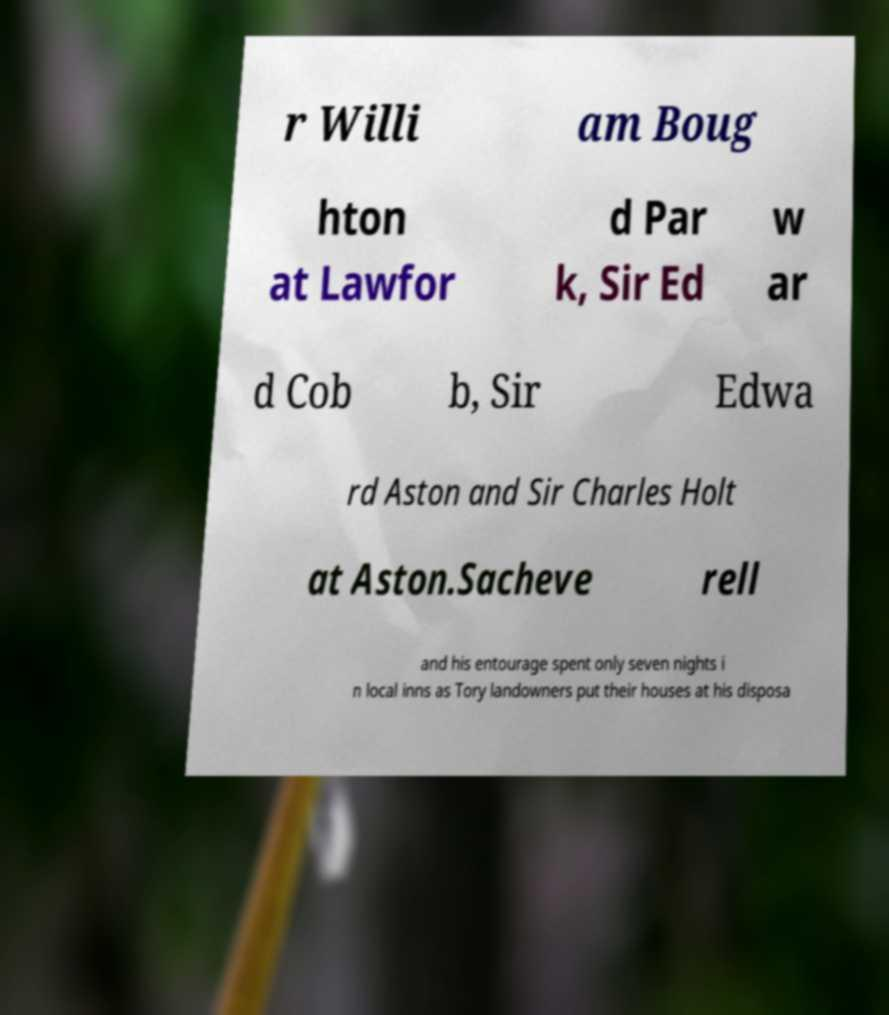For documentation purposes, I need the text within this image transcribed. Could you provide that? r Willi am Boug hton at Lawfor d Par k, Sir Ed w ar d Cob b, Sir Edwa rd Aston and Sir Charles Holt at Aston.Sacheve rell and his entourage spent only seven nights i n local inns as Tory landowners put their houses at his disposa 